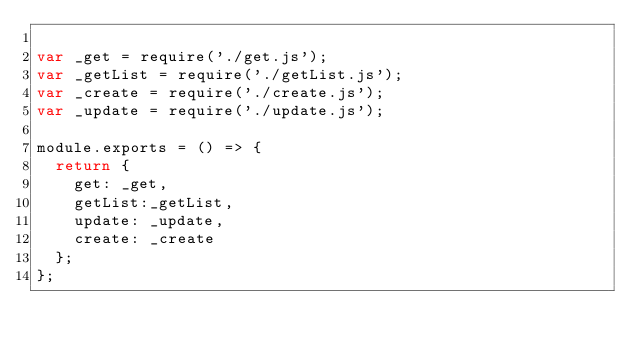Convert code to text. <code><loc_0><loc_0><loc_500><loc_500><_JavaScript_>
var _get = require('./get.js');
var _getList = require('./getList.js');
var _create = require('./create.js');
var _update = require('./update.js');

module.exports = () => {
  return {
    get: _get,
    getList:_getList,
    update: _update,
    create: _create
  };
};</code> 